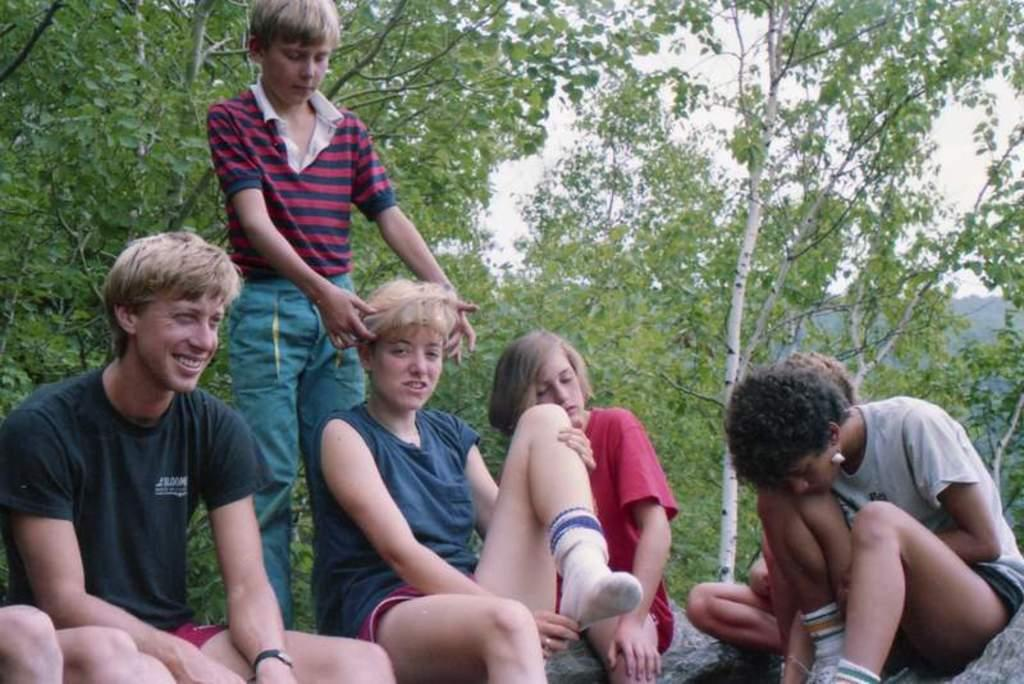How many people are in the image? There are people in the image, but the exact number is not specified. Can you describe the position of the boy in the image? One boy is standing among the people in the image. What are the other people doing in the image? Other people are sitting on the ground in the image. What can be seen in the background of the image? There is a sky and trees visible in the background of the image. What type of pie is being sold at the market in the image? There is no market or pie present in the image; it features people standing and sitting in a setting with a sky and trees in the background. What message is conveyed by the sign in the image? There is no sign present in the image. 